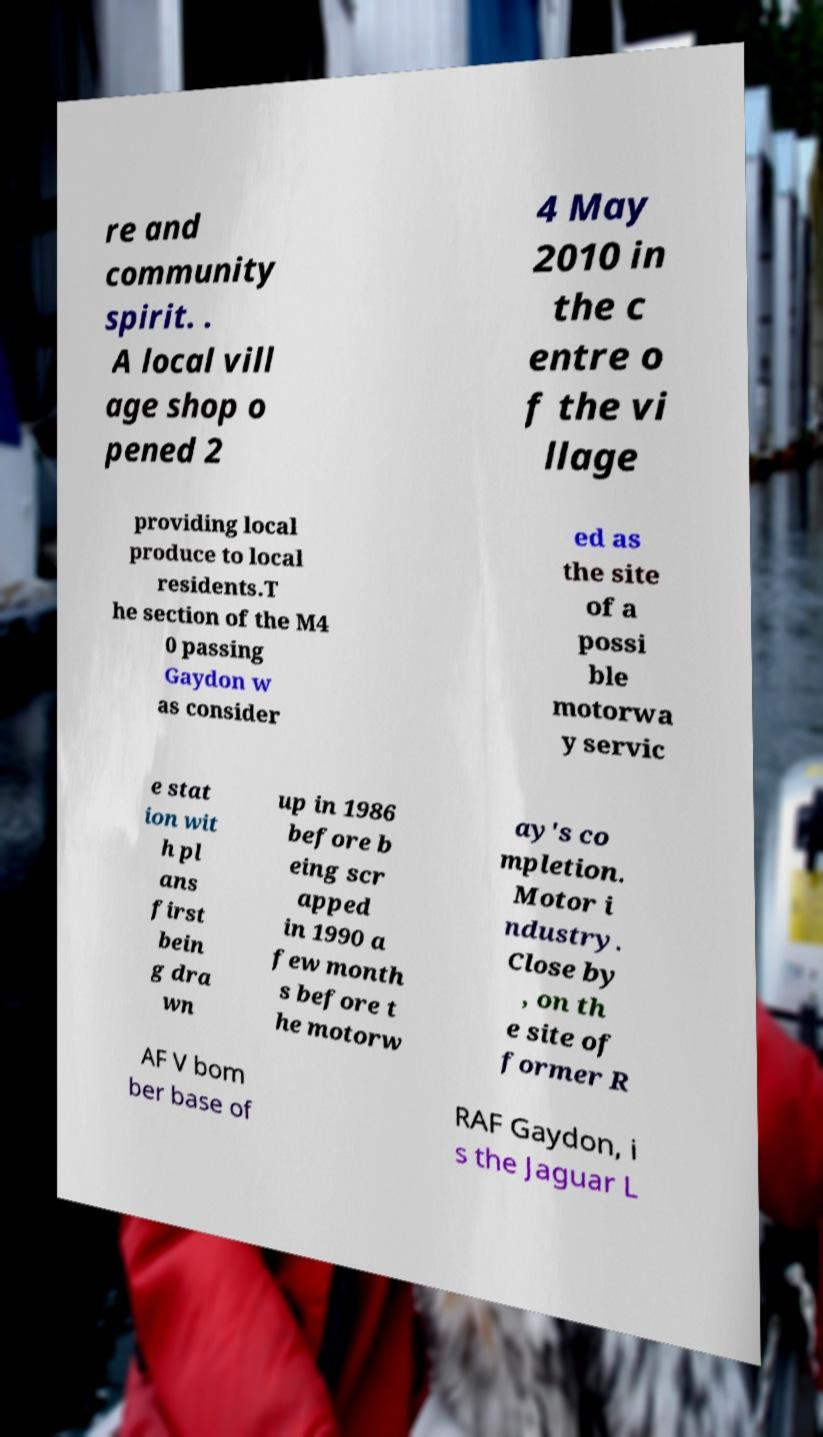For documentation purposes, I need the text within this image transcribed. Could you provide that? re and community spirit. . A local vill age shop o pened 2 4 May 2010 in the c entre o f the vi llage providing local produce to local residents.T he section of the M4 0 passing Gaydon w as consider ed as the site of a possi ble motorwa y servic e stat ion wit h pl ans first bein g dra wn up in 1986 before b eing scr apped in 1990 a few month s before t he motorw ay's co mpletion. Motor i ndustry. Close by , on th e site of former R AF V bom ber base of RAF Gaydon, i s the Jaguar L 